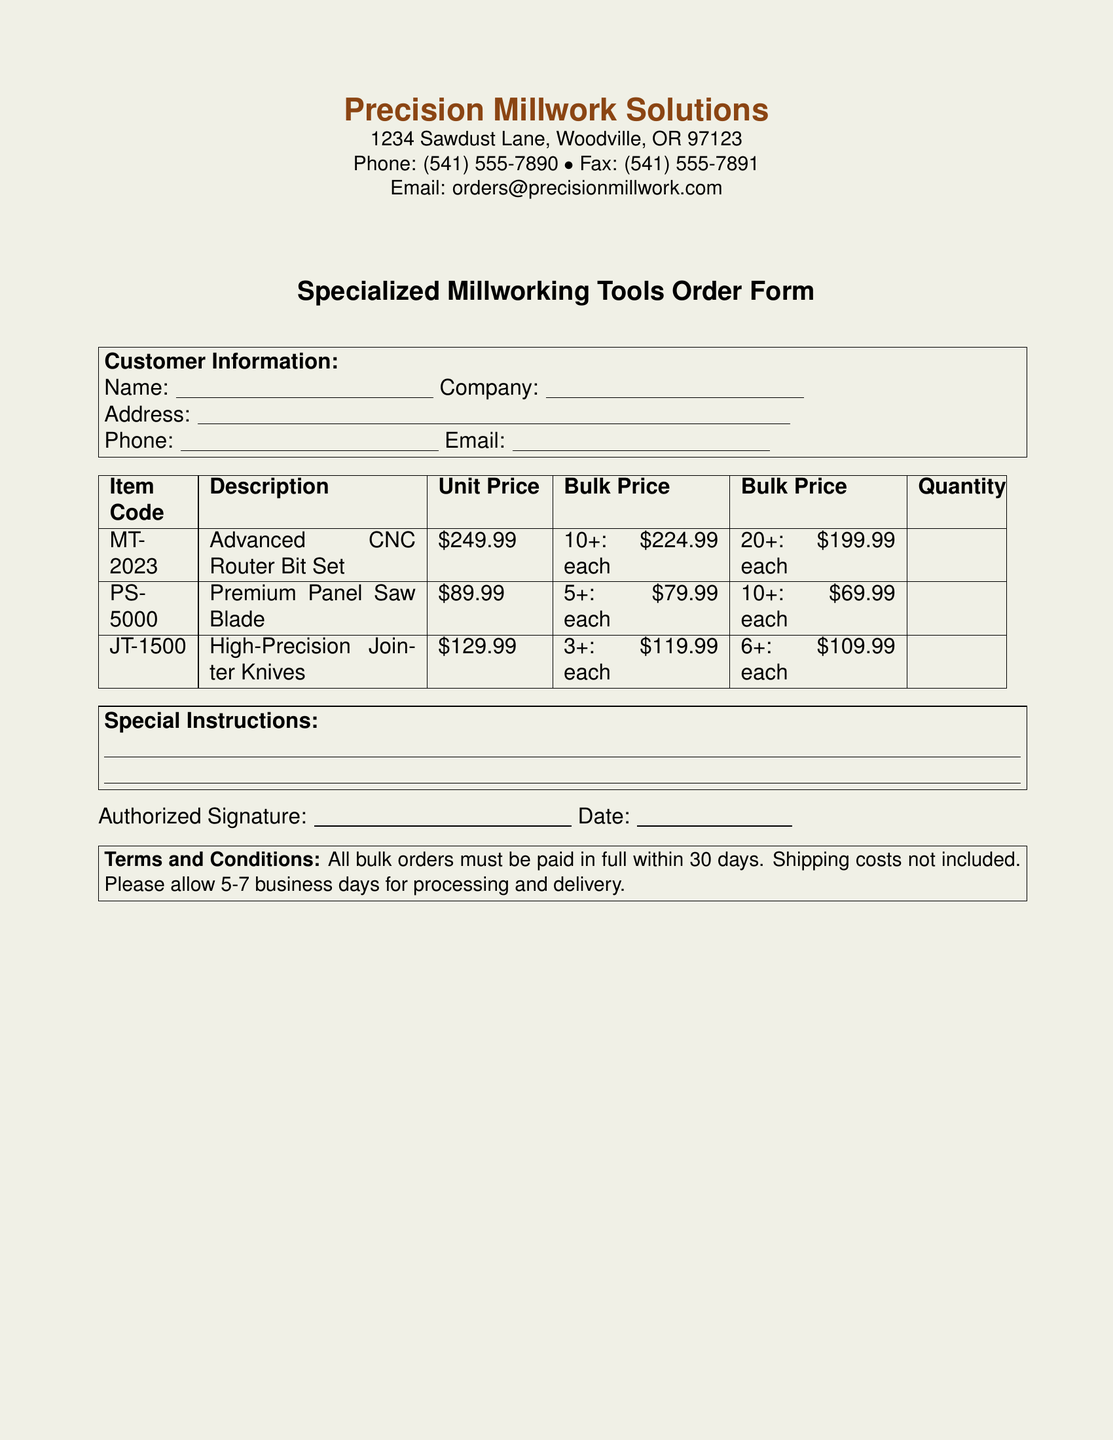What is the company name? The company name is at the top of the document, listed as "Precision Millwork Solutions."
Answer: Precision Millwork Solutions What is the unit price of the Advanced CNC Router Bit Set? The unit price for the Advanced CNC Router Bit Set is stated in the table under the "Unit Price" column.
Answer: $249.99 What is the bulk price for 20 or more Premium Panel Saw Blades? The bulk price for purchasing 20 or more Premium Panel Saw Blades is listed in the table under the corresponding segment.
Answer: $69.99 each What is the minimum quantity required to get the bulk price on High-Precision Jointer Knives? The bulk pricing for High-Precision Jointer Knives starts at a specified minimum quantity, found in the table.
Answer: 3+ What is the deadline for payment on bulk orders? The payment terms for bulk orders are mentioned in the "Terms and Conditions" section of the document.
Answer: 30 days What kind of tools does this order form pertain to? The document specifies the types of tools associated with this order form in the title and the table's descriptions.
Answer: Specialized millworking tools What should customers allow for processing and delivery? The document states the expected timeframe for processing and delivery within the "Terms and Conditions."
Answer: 5-7 business days What type of form is this document categorized as? The document is identified by its specific structure and purpose, which is indicated prominently at the center.
Answer: Order Form 